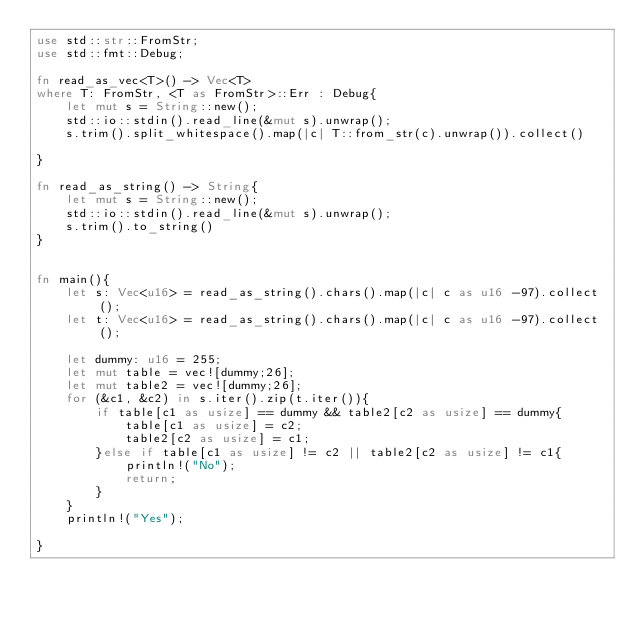Convert code to text. <code><loc_0><loc_0><loc_500><loc_500><_Rust_>use std::str::FromStr;
use std::fmt::Debug;

fn read_as_vec<T>() -> Vec<T>
where T: FromStr, <T as FromStr>::Err : Debug{
    let mut s = String::new();
    std::io::stdin().read_line(&mut s).unwrap();
    s.trim().split_whitespace().map(|c| T::from_str(c).unwrap()).collect()

}

fn read_as_string() -> String{
    let mut s = String::new();
    std::io::stdin().read_line(&mut s).unwrap();
    s.trim().to_string()
}


fn main(){
    let s: Vec<u16> = read_as_string().chars().map(|c| c as u16 -97).collect();
    let t: Vec<u16> = read_as_string().chars().map(|c| c as u16 -97).collect();

    let dummy: u16 = 255;
    let mut table = vec![dummy;26];
    let mut table2 = vec![dummy;26];
    for (&c1, &c2) in s.iter().zip(t.iter()){
        if table[c1 as usize] == dummy && table2[c2 as usize] == dummy{
            table[c1 as usize] = c2;
            table2[c2 as usize] = c1;
        }else if table[c1 as usize] != c2 || table2[c2 as usize] != c1{
            println!("No");
            return;
        }
    }
    println!("Yes");
    
}
</code> 